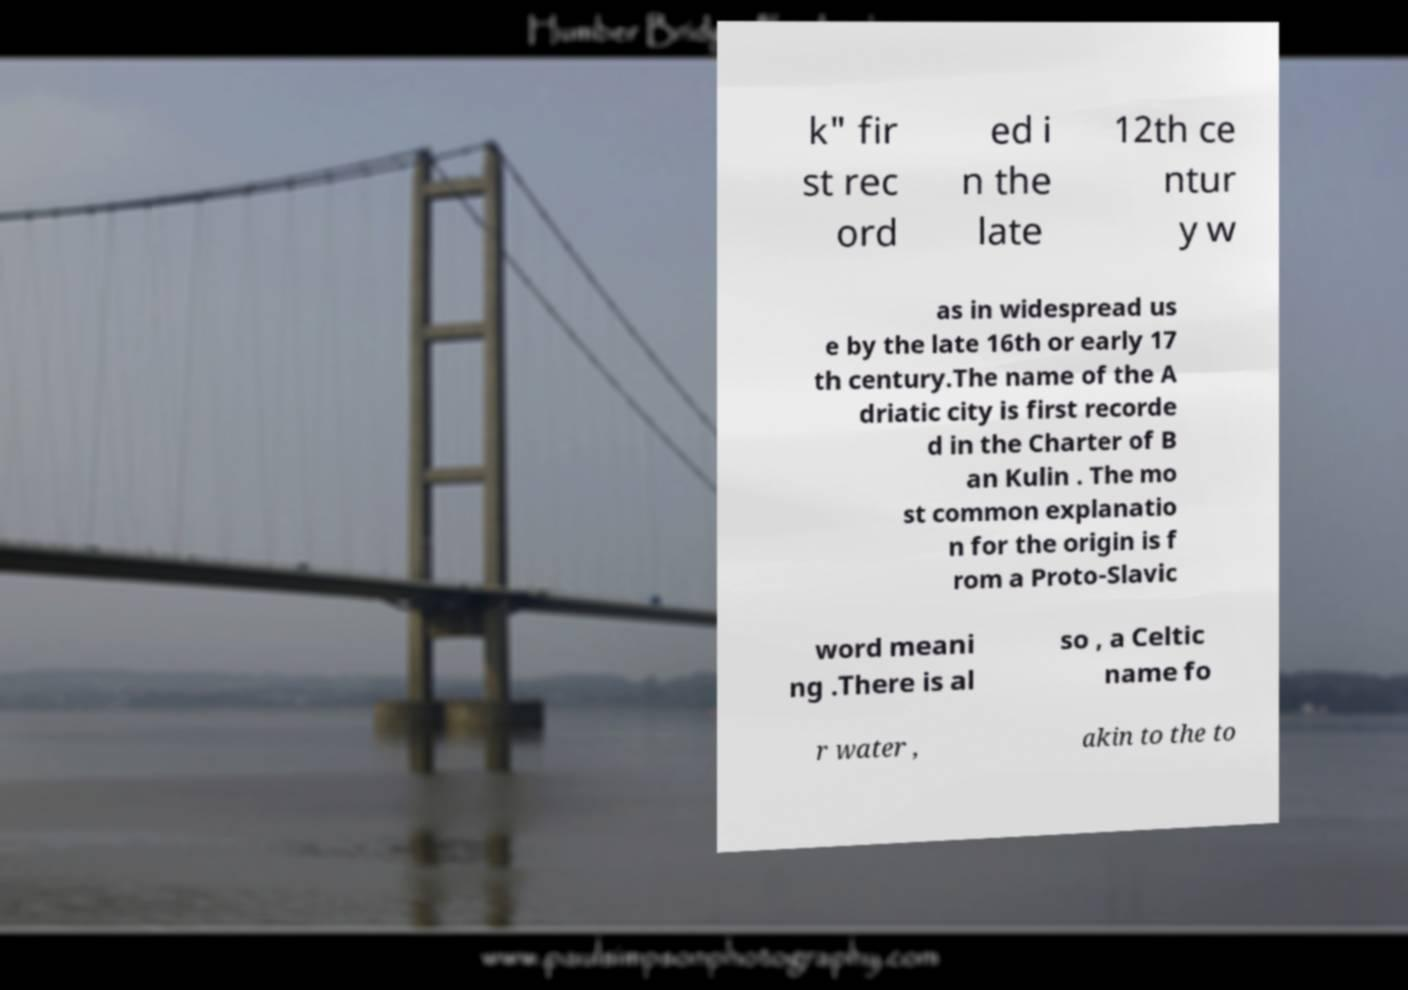There's text embedded in this image that I need extracted. Can you transcribe it verbatim? k" fir st rec ord ed i n the late 12th ce ntur y w as in widespread us e by the late 16th or early 17 th century.The name of the A driatic city is first recorde d in the Charter of B an Kulin . The mo st common explanatio n for the origin is f rom a Proto-Slavic word meani ng .There is al so , a Celtic name fo r water , akin to the to 